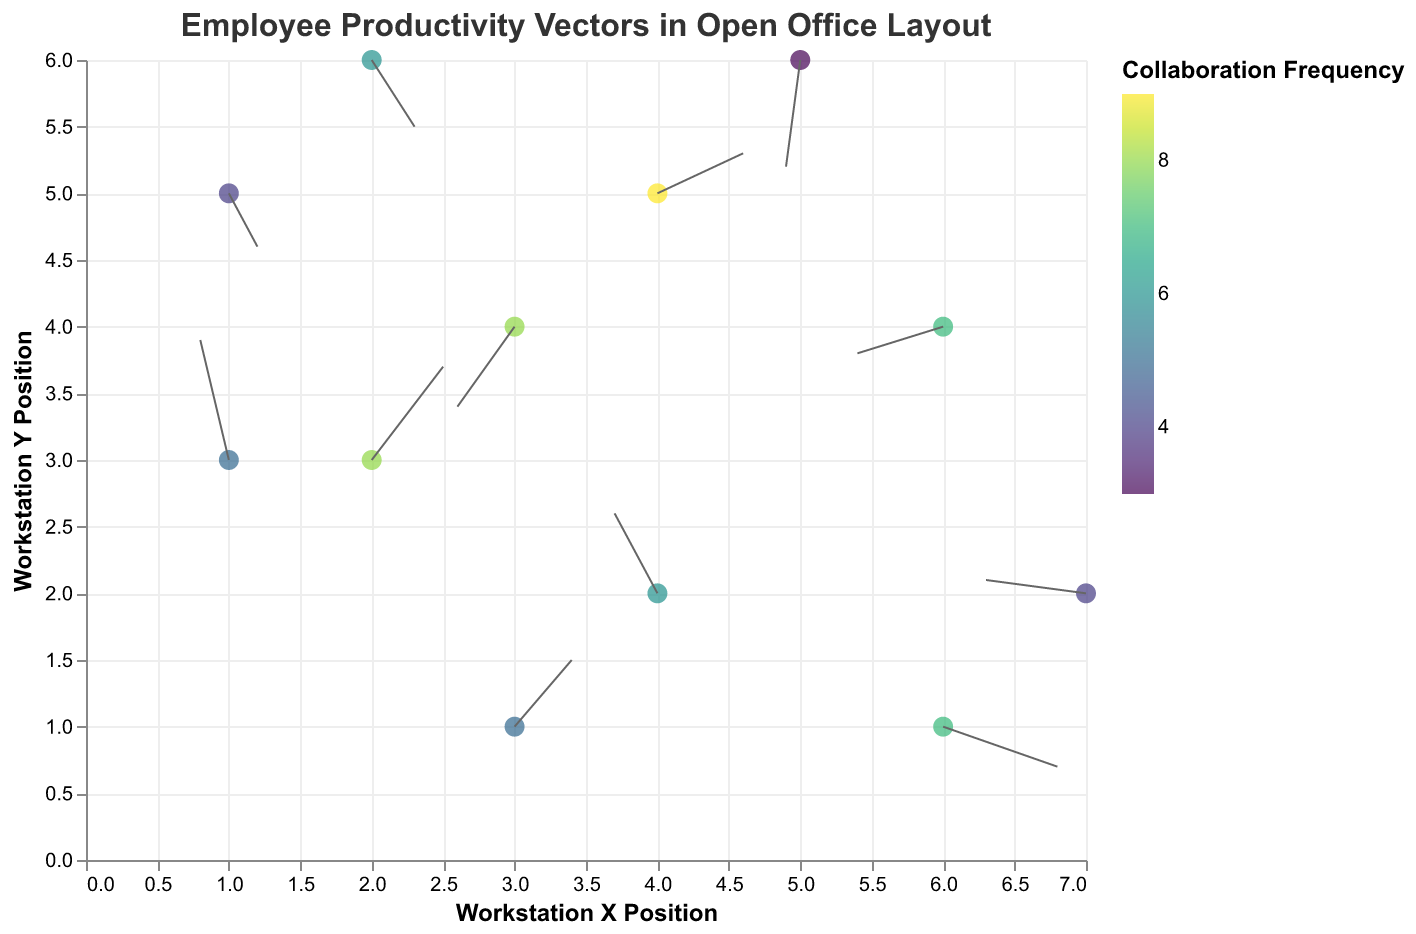What is the title of the figure? The title is written at the top of the figure and provides a summary of its content. The title reads "Employee Productivity Vectors in Open Office Layout", indicating that the plot shows productivity vectors of employees in an open office setting.
Answer: Employee Productivity Vectors in Open Office Layout How many data points are displayed in the figure? The figure shows data points where the vectors originate, corresponding to the positions of the workstations. By counting the number of points marked on the plot, it becomes clear that there are 12 data points.
Answer: 12 What are the axes titles and their units? The axes titles are displayed along the x and y axes. The x-axis is labeled "Workstation X Position", and the y-axis is labeled "Workstation Y Position". Both axes typically represent numeric workspace coordinates, but no specific units are indicated in this plot.
Answer: Workstation X Position and Workstation Y Position Which workstation has the highest collaboration frequency, and what is the value? Collaboration frequency is indicated by the color of the points on the plot. By examining the color scale and matching it to the points, the workstation at position (4,5) has the highest collaboration frequency of 9.
Answer: (4,5) with a value of 9 How many workstations have a collaboration frequency greater than 6? The color scale visually indicates collaboration frequency. By inspecting the color of each workstation's point and comparing them to the scale, it is found that four workstations have collaboration frequencies greater than 6.
Answer: 4 Which workstation has the longest vector, and what are its components (u, v)? The length of the vector can be visually estimated by its overall size. Closer inspection of the data points reveals that the workstation at position (6,1) has a vector with the longest components, specifically (u=0.8, v=-0.3).
Answer: (6,1) with components (0.8, -0.3) Which workstation has the smallest vector, and what is its length? The length of the vector can be calculated as sqrt(u^2 + v^2). By inspecting each vector, the workstation at (5,6) has a vector with components (u=-0.1, v=-0.8). The calculated length is sqrt((-0.1)^2 + (-0.8)^2) = sqrt(0.01 + 0.64) ≈ 0.81, making it the smallest vector.
Answer: (5,6) with length ≈ 0.81 Which two workstations are closest in position? Workstation proximity is determined by calculating the Euclidean distance between each pair of points. The distance between (4,5) and (3,4) is calculated as sqrt((4-3)^2 + (5-4)^2) = sqrt(1 + 1) = sqrt(2). No other pair has a smaller distance, making them the closest.
Answer: (4,5) and (3,4) What is the average collaboration frequency of all workstations? To find the average collaboration frequency, sum up all frequencies and divide by the number of workstations. The sum is 8 + 6 + 4 + 7 + 5 + 3 + 6 + 4 + 9 + 5 + 7 + 8 = 72. The average is 72 / 12 = 6.
Answer: 6 